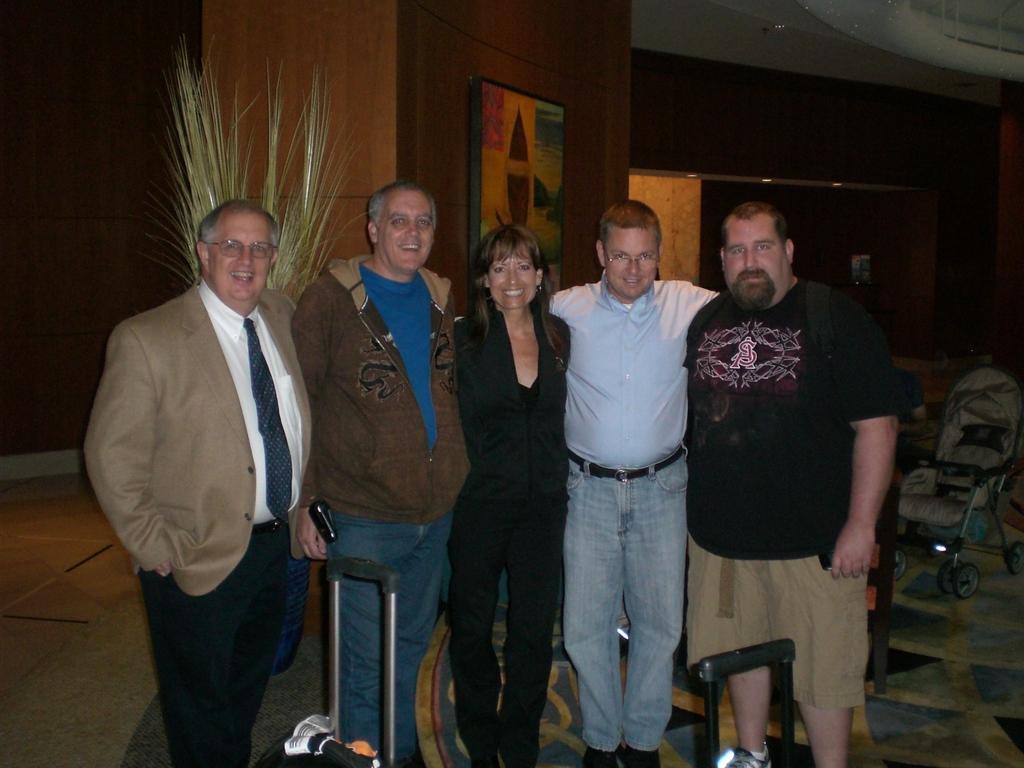In one or two sentences, can you explain what this image depicts? In this image there are four men and a woman standing, there are two suitcases in front of them and in the background there is a baby stroller. 